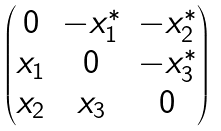Convert formula to latex. <formula><loc_0><loc_0><loc_500><loc_500>\begin{pmatrix} 0 & - x _ { 1 } ^ { * } & - x _ { 2 } ^ { * } \\ x _ { 1 } & 0 & - x _ { 3 } ^ { * } \\ x _ { 2 } & x _ { 3 } & 0 \end{pmatrix}</formula> 